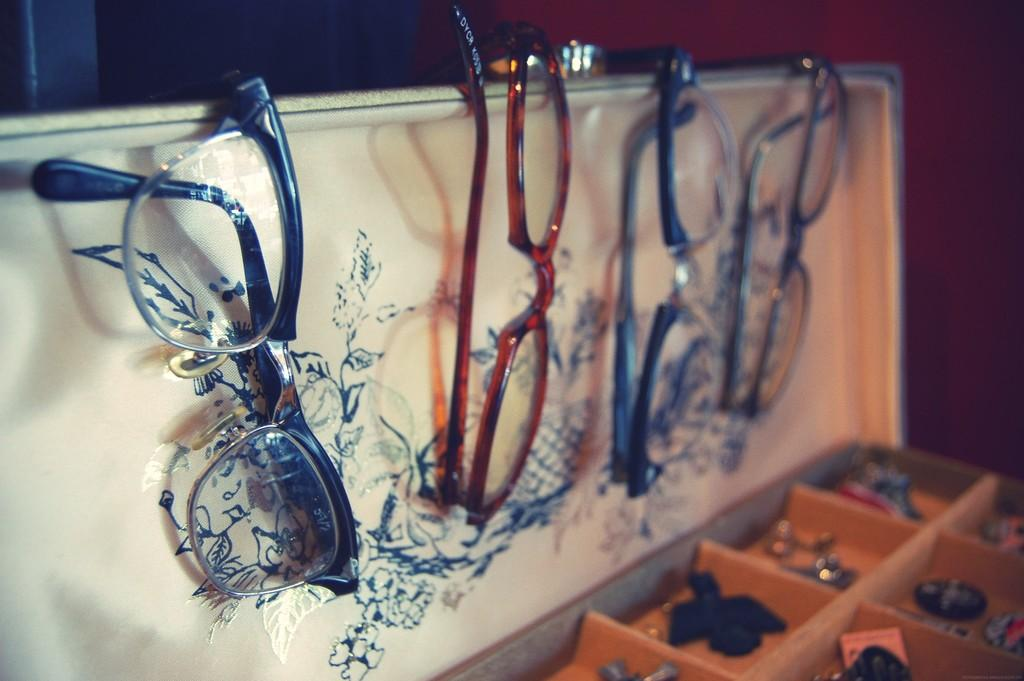What type of accessory is present in the image? There are spectacles in the image. What objects are contained within the boxes in the image? There are items in boxes in the image. What is the color of the background in the image? The background of the image is dark. Can you tell me how many cacti are visible in the image? There are no cacti present in the image. What type of art is being created in the image? There is no art being created in the image. 